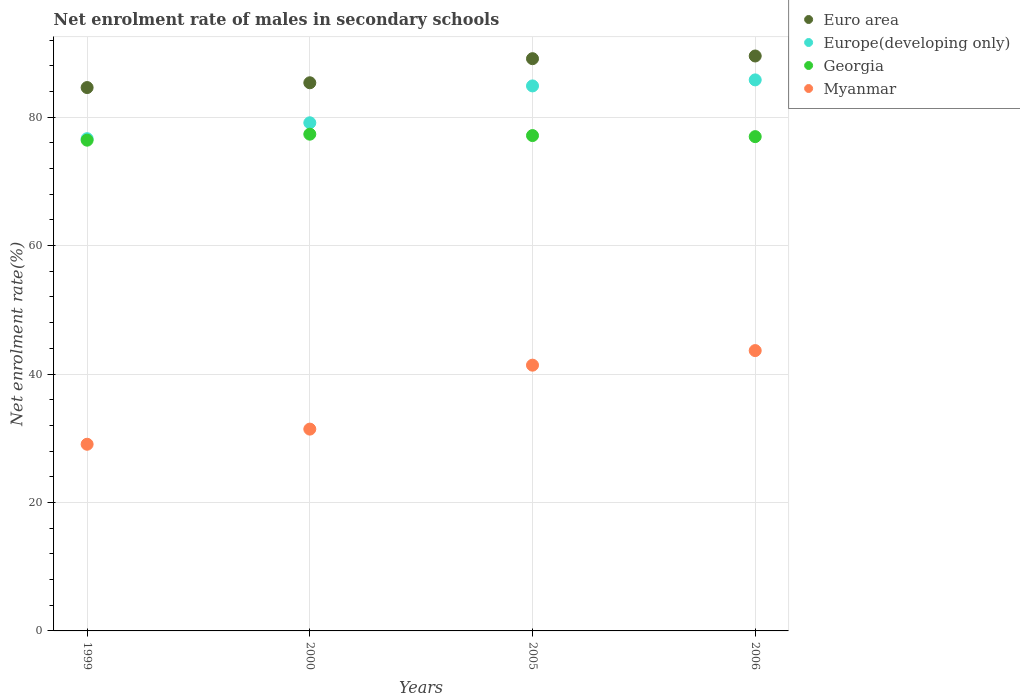What is the net enrolment rate of males in secondary schools in Europe(developing only) in 2000?
Give a very brief answer. 79.12. Across all years, what is the maximum net enrolment rate of males in secondary schools in Euro area?
Your response must be concise. 89.52. Across all years, what is the minimum net enrolment rate of males in secondary schools in Myanmar?
Offer a terse response. 29.06. In which year was the net enrolment rate of males in secondary schools in Myanmar maximum?
Your answer should be very brief. 2006. What is the total net enrolment rate of males in secondary schools in Euro area in the graph?
Your response must be concise. 348.56. What is the difference between the net enrolment rate of males in secondary schools in Euro area in 1999 and that in 2005?
Provide a succinct answer. -4.49. What is the difference between the net enrolment rate of males in secondary schools in Euro area in 2006 and the net enrolment rate of males in secondary schools in Myanmar in 2005?
Keep it short and to the point. 48.14. What is the average net enrolment rate of males in secondary schools in Georgia per year?
Give a very brief answer. 76.96. In the year 1999, what is the difference between the net enrolment rate of males in secondary schools in Georgia and net enrolment rate of males in secondary schools in Myanmar?
Make the answer very short. 47.35. What is the ratio of the net enrolment rate of males in secondary schools in Myanmar in 2000 to that in 2005?
Give a very brief answer. 0.76. Is the difference between the net enrolment rate of males in secondary schools in Georgia in 1999 and 2005 greater than the difference between the net enrolment rate of males in secondary schools in Myanmar in 1999 and 2005?
Offer a terse response. Yes. What is the difference between the highest and the second highest net enrolment rate of males in secondary schools in Georgia?
Ensure brevity in your answer.  0.22. What is the difference between the highest and the lowest net enrolment rate of males in secondary schools in Myanmar?
Your answer should be compact. 14.58. In how many years, is the net enrolment rate of males in secondary schools in Euro area greater than the average net enrolment rate of males in secondary schools in Euro area taken over all years?
Your answer should be very brief. 2. Does the net enrolment rate of males in secondary schools in Georgia monotonically increase over the years?
Provide a short and direct response. No. Is the net enrolment rate of males in secondary schools in Euro area strictly greater than the net enrolment rate of males in secondary schools in Europe(developing only) over the years?
Offer a very short reply. Yes. How many dotlines are there?
Offer a terse response. 4. Are the values on the major ticks of Y-axis written in scientific E-notation?
Make the answer very short. No. How many legend labels are there?
Provide a succinct answer. 4. What is the title of the graph?
Ensure brevity in your answer.  Net enrolment rate of males in secondary schools. What is the label or title of the X-axis?
Your answer should be compact. Years. What is the label or title of the Y-axis?
Offer a terse response. Net enrolment rate(%). What is the Net enrolment rate(%) in Euro area in 1999?
Provide a short and direct response. 84.6. What is the Net enrolment rate(%) in Europe(developing only) in 1999?
Offer a very short reply. 76.64. What is the Net enrolment rate(%) in Georgia in 1999?
Provide a succinct answer. 76.41. What is the Net enrolment rate(%) of Myanmar in 1999?
Your answer should be compact. 29.06. What is the Net enrolment rate(%) of Euro area in 2000?
Keep it short and to the point. 85.35. What is the Net enrolment rate(%) in Europe(developing only) in 2000?
Provide a succinct answer. 79.12. What is the Net enrolment rate(%) of Georgia in 2000?
Give a very brief answer. 77.34. What is the Net enrolment rate(%) in Myanmar in 2000?
Offer a very short reply. 31.42. What is the Net enrolment rate(%) of Euro area in 2005?
Offer a very short reply. 89.1. What is the Net enrolment rate(%) of Europe(developing only) in 2005?
Ensure brevity in your answer.  84.86. What is the Net enrolment rate(%) of Georgia in 2005?
Your answer should be compact. 77.13. What is the Net enrolment rate(%) of Myanmar in 2005?
Your response must be concise. 41.38. What is the Net enrolment rate(%) of Euro area in 2006?
Provide a succinct answer. 89.52. What is the Net enrolment rate(%) of Europe(developing only) in 2006?
Your answer should be very brief. 85.79. What is the Net enrolment rate(%) in Georgia in 2006?
Provide a short and direct response. 76.96. What is the Net enrolment rate(%) of Myanmar in 2006?
Your response must be concise. 43.65. Across all years, what is the maximum Net enrolment rate(%) in Euro area?
Provide a succinct answer. 89.52. Across all years, what is the maximum Net enrolment rate(%) of Europe(developing only)?
Offer a terse response. 85.79. Across all years, what is the maximum Net enrolment rate(%) of Georgia?
Provide a short and direct response. 77.34. Across all years, what is the maximum Net enrolment rate(%) of Myanmar?
Provide a succinct answer. 43.65. Across all years, what is the minimum Net enrolment rate(%) of Euro area?
Offer a terse response. 84.6. Across all years, what is the minimum Net enrolment rate(%) in Europe(developing only)?
Give a very brief answer. 76.64. Across all years, what is the minimum Net enrolment rate(%) in Georgia?
Offer a very short reply. 76.41. Across all years, what is the minimum Net enrolment rate(%) in Myanmar?
Your answer should be compact. 29.06. What is the total Net enrolment rate(%) of Euro area in the graph?
Provide a succinct answer. 348.56. What is the total Net enrolment rate(%) of Europe(developing only) in the graph?
Give a very brief answer. 326.41. What is the total Net enrolment rate(%) of Georgia in the graph?
Offer a terse response. 307.84. What is the total Net enrolment rate(%) of Myanmar in the graph?
Your answer should be very brief. 145.51. What is the difference between the Net enrolment rate(%) of Euro area in 1999 and that in 2000?
Ensure brevity in your answer.  -0.74. What is the difference between the Net enrolment rate(%) in Europe(developing only) in 1999 and that in 2000?
Provide a short and direct response. -2.48. What is the difference between the Net enrolment rate(%) in Georgia in 1999 and that in 2000?
Provide a short and direct response. -0.93. What is the difference between the Net enrolment rate(%) in Myanmar in 1999 and that in 2000?
Offer a very short reply. -2.36. What is the difference between the Net enrolment rate(%) of Euro area in 1999 and that in 2005?
Give a very brief answer. -4.49. What is the difference between the Net enrolment rate(%) in Europe(developing only) in 1999 and that in 2005?
Provide a short and direct response. -8.22. What is the difference between the Net enrolment rate(%) of Georgia in 1999 and that in 2005?
Your answer should be compact. -0.72. What is the difference between the Net enrolment rate(%) of Myanmar in 1999 and that in 2005?
Keep it short and to the point. -12.31. What is the difference between the Net enrolment rate(%) in Euro area in 1999 and that in 2006?
Offer a very short reply. -4.91. What is the difference between the Net enrolment rate(%) in Europe(developing only) in 1999 and that in 2006?
Ensure brevity in your answer.  -9.16. What is the difference between the Net enrolment rate(%) in Georgia in 1999 and that in 2006?
Provide a succinct answer. -0.55. What is the difference between the Net enrolment rate(%) in Myanmar in 1999 and that in 2006?
Offer a terse response. -14.58. What is the difference between the Net enrolment rate(%) of Euro area in 2000 and that in 2005?
Ensure brevity in your answer.  -3.75. What is the difference between the Net enrolment rate(%) of Europe(developing only) in 2000 and that in 2005?
Give a very brief answer. -5.74. What is the difference between the Net enrolment rate(%) in Georgia in 2000 and that in 2005?
Your answer should be compact. 0.22. What is the difference between the Net enrolment rate(%) in Myanmar in 2000 and that in 2005?
Ensure brevity in your answer.  -9.96. What is the difference between the Net enrolment rate(%) of Euro area in 2000 and that in 2006?
Keep it short and to the point. -4.17. What is the difference between the Net enrolment rate(%) in Europe(developing only) in 2000 and that in 2006?
Your answer should be compact. -6.68. What is the difference between the Net enrolment rate(%) in Georgia in 2000 and that in 2006?
Offer a terse response. 0.38. What is the difference between the Net enrolment rate(%) of Myanmar in 2000 and that in 2006?
Make the answer very short. -12.23. What is the difference between the Net enrolment rate(%) in Euro area in 2005 and that in 2006?
Give a very brief answer. -0.42. What is the difference between the Net enrolment rate(%) in Europe(developing only) in 2005 and that in 2006?
Give a very brief answer. -0.94. What is the difference between the Net enrolment rate(%) of Georgia in 2005 and that in 2006?
Make the answer very short. 0.17. What is the difference between the Net enrolment rate(%) in Myanmar in 2005 and that in 2006?
Your response must be concise. -2.27. What is the difference between the Net enrolment rate(%) of Euro area in 1999 and the Net enrolment rate(%) of Europe(developing only) in 2000?
Offer a very short reply. 5.49. What is the difference between the Net enrolment rate(%) of Euro area in 1999 and the Net enrolment rate(%) of Georgia in 2000?
Offer a terse response. 7.26. What is the difference between the Net enrolment rate(%) in Euro area in 1999 and the Net enrolment rate(%) in Myanmar in 2000?
Make the answer very short. 53.18. What is the difference between the Net enrolment rate(%) of Europe(developing only) in 1999 and the Net enrolment rate(%) of Georgia in 2000?
Your answer should be compact. -0.7. What is the difference between the Net enrolment rate(%) in Europe(developing only) in 1999 and the Net enrolment rate(%) in Myanmar in 2000?
Offer a very short reply. 45.22. What is the difference between the Net enrolment rate(%) of Georgia in 1999 and the Net enrolment rate(%) of Myanmar in 2000?
Ensure brevity in your answer.  44.99. What is the difference between the Net enrolment rate(%) in Euro area in 1999 and the Net enrolment rate(%) in Europe(developing only) in 2005?
Your answer should be very brief. -0.25. What is the difference between the Net enrolment rate(%) in Euro area in 1999 and the Net enrolment rate(%) in Georgia in 2005?
Make the answer very short. 7.48. What is the difference between the Net enrolment rate(%) in Euro area in 1999 and the Net enrolment rate(%) in Myanmar in 2005?
Ensure brevity in your answer.  43.22. What is the difference between the Net enrolment rate(%) in Europe(developing only) in 1999 and the Net enrolment rate(%) in Georgia in 2005?
Offer a very short reply. -0.49. What is the difference between the Net enrolment rate(%) in Europe(developing only) in 1999 and the Net enrolment rate(%) in Myanmar in 2005?
Your response must be concise. 35.26. What is the difference between the Net enrolment rate(%) of Georgia in 1999 and the Net enrolment rate(%) of Myanmar in 2005?
Offer a terse response. 35.03. What is the difference between the Net enrolment rate(%) in Euro area in 1999 and the Net enrolment rate(%) in Europe(developing only) in 2006?
Your answer should be compact. -1.19. What is the difference between the Net enrolment rate(%) in Euro area in 1999 and the Net enrolment rate(%) in Georgia in 2006?
Give a very brief answer. 7.64. What is the difference between the Net enrolment rate(%) in Euro area in 1999 and the Net enrolment rate(%) in Myanmar in 2006?
Offer a terse response. 40.95. What is the difference between the Net enrolment rate(%) in Europe(developing only) in 1999 and the Net enrolment rate(%) in Georgia in 2006?
Keep it short and to the point. -0.32. What is the difference between the Net enrolment rate(%) in Europe(developing only) in 1999 and the Net enrolment rate(%) in Myanmar in 2006?
Make the answer very short. 32.99. What is the difference between the Net enrolment rate(%) in Georgia in 1999 and the Net enrolment rate(%) in Myanmar in 2006?
Offer a terse response. 32.76. What is the difference between the Net enrolment rate(%) in Euro area in 2000 and the Net enrolment rate(%) in Europe(developing only) in 2005?
Give a very brief answer. 0.49. What is the difference between the Net enrolment rate(%) of Euro area in 2000 and the Net enrolment rate(%) of Georgia in 2005?
Offer a very short reply. 8.22. What is the difference between the Net enrolment rate(%) in Euro area in 2000 and the Net enrolment rate(%) in Myanmar in 2005?
Give a very brief answer. 43.97. What is the difference between the Net enrolment rate(%) in Europe(developing only) in 2000 and the Net enrolment rate(%) in Georgia in 2005?
Give a very brief answer. 1.99. What is the difference between the Net enrolment rate(%) in Europe(developing only) in 2000 and the Net enrolment rate(%) in Myanmar in 2005?
Provide a short and direct response. 37.74. What is the difference between the Net enrolment rate(%) of Georgia in 2000 and the Net enrolment rate(%) of Myanmar in 2005?
Make the answer very short. 35.96. What is the difference between the Net enrolment rate(%) in Euro area in 2000 and the Net enrolment rate(%) in Europe(developing only) in 2006?
Provide a short and direct response. -0.45. What is the difference between the Net enrolment rate(%) of Euro area in 2000 and the Net enrolment rate(%) of Georgia in 2006?
Provide a short and direct response. 8.39. What is the difference between the Net enrolment rate(%) in Euro area in 2000 and the Net enrolment rate(%) in Myanmar in 2006?
Provide a short and direct response. 41.7. What is the difference between the Net enrolment rate(%) in Europe(developing only) in 2000 and the Net enrolment rate(%) in Georgia in 2006?
Provide a succinct answer. 2.16. What is the difference between the Net enrolment rate(%) in Europe(developing only) in 2000 and the Net enrolment rate(%) in Myanmar in 2006?
Make the answer very short. 35.47. What is the difference between the Net enrolment rate(%) in Georgia in 2000 and the Net enrolment rate(%) in Myanmar in 2006?
Keep it short and to the point. 33.69. What is the difference between the Net enrolment rate(%) of Euro area in 2005 and the Net enrolment rate(%) of Europe(developing only) in 2006?
Your answer should be very brief. 3.3. What is the difference between the Net enrolment rate(%) in Euro area in 2005 and the Net enrolment rate(%) in Georgia in 2006?
Offer a terse response. 12.14. What is the difference between the Net enrolment rate(%) of Euro area in 2005 and the Net enrolment rate(%) of Myanmar in 2006?
Give a very brief answer. 45.45. What is the difference between the Net enrolment rate(%) of Europe(developing only) in 2005 and the Net enrolment rate(%) of Georgia in 2006?
Keep it short and to the point. 7.9. What is the difference between the Net enrolment rate(%) in Europe(developing only) in 2005 and the Net enrolment rate(%) in Myanmar in 2006?
Offer a terse response. 41.21. What is the difference between the Net enrolment rate(%) in Georgia in 2005 and the Net enrolment rate(%) in Myanmar in 2006?
Ensure brevity in your answer.  33.48. What is the average Net enrolment rate(%) of Euro area per year?
Keep it short and to the point. 87.14. What is the average Net enrolment rate(%) of Europe(developing only) per year?
Keep it short and to the point. 81.6. What is the average Net enrolment rate(%) of Georgia per year?
Provide a succinct answer. 76.96. What is the average Net enrolment rate(%) of Myanmar per year?
Provide a succinct answer. 36.38. In the year 1999, what is the difference between the Net enrolment rate(%) in Euro area and Net enrolment rate(%) in Europe(developing only)?
Your answer should be very brief. 7.96. In the year 1999, what is the difference between the Net enrolment rate(%) in Euro area and Net enrolment rate(%) in Georgia?
Give a very brief answer. 8.19. In the year 1999, what is the difference between the Net enrolment rate(%) in Euro area and Net enrolment rate(%) in Myanmar?
Your response must be concise. 55.54. In the year 1999, what is the difference between the Net enrolment rate(%) in Europe(developing only) and Net enrolment rate(%) in Georgia?
Make the answer very short. 0.23. In the year 1999, what is the difference between the Net enrolment rate(%) in Europe(developing only) and Net enrolment rate(%) in Myanmar?
Offer a terse response. 47.57. In the year 1999, what is the difference between the Net enrolment rate(%) in Georgia and Net enrolment rate(%) in Myanmar?
Your response must be concise. 47.35. In the year 2000, what is the difference between the Net enrolment rate(%) of Euro area and Net enrolment rate(%) of Europe(developing only)?
Ensure brevity in your answer.  6.23. In the year 2000, what is the difference between the Net enrolment rate(%) in Euro area and Net enrolment rate(%) in Georgia?
Ensure brevity in your answer.  8. In the year 2000, what is the difference between the Net enrolment rate(%) in Euro area and Net enrolment rate(%) in Myanmar?
Provide a short and direct response. 53.92. In the year 2000, what is the difference between the Net enrolment rate(%) in Europe(developing only) and Net enrolment rate(%) in Georgia?
Your answer should be very brief. 1.78. In the year 2000, what is the difference between the Net enrolment rate(%) in Europe(developing only) and Net enrolment rate(%) in Myanmar?
Your answer should be compact. 47.7. In the year 2000, what is the difference between the Net enrolment rate(%) in Georgia and Net enrolment rate(%) in Myanmar?
Your answer should be very brief. 45.92. In the year 2005, what is the difference between the Net enrolment rate(%) of Euro area and Net enrolment rate(%) of Europe(developing only)?
Make the answer very short. 4.24. In the year 2005, what is the difference between the Net enrolment rate(%) of Euro area and Net enrolment rate(%) of Georgia?
Offer a terse response. 11.97. In the year 2005, what is the difference between the Net enrolment rate(%) of Euro area and Net enrolment rate(%) of Myanmar?
Keep it short and to the point. 47.72. In the year 2005, what is the difference between the Net enrolment rate(%) in Europe(developing only) and Net enrolment rate(%) in Georgia?
Your answer should be compact. 7.73. In the year 2005, what is the difference between the Net enrolment rate(%) in Europe(developing only) and Net enrolment rate(%) in Myanmar?
Provide a succinct answer. 43.48. In the year 2005, what is the difference between the Net enrolment rate(%) of Georgia and Net enrolment rate(%) of Myanmar?
Provide a short and direct response. 35.75. In the year 2006, what is the difference between the Net enrolment rate(%) in Euro area and Net enrolment rate(%) in Europe(developing only)?
Provide a short and direct response. 3.72. In the year 2006, what is the difference between the Net enrolment rate(%) of Euro area and Net enrolment rate(%) of Georgia?
Give a very brief answer. 12.56. In the year 2006, what is the difference between the Net enrolment rate(%) in Euro area and Net enrolment rate(%) in Myanmar?
Keep it short and to the point. 45.87. In the year 2006, what is the difference between the Net enrolment rate(%) of Europe(developing only) and Net enrolment rate(%) of Georgia?
Your answer should be very brief. 8.84. In the year 2006, what is the difference between the Net enrolment rate(%) of Europe(developing only) and Net enrolment rate(%) of Myanmar?
Offer a very short reply. 42.15. In the year 2006, what is the difference between the Net enrolment rate(%) of Georgia and Net enrolment rate(%) of Myanmar?
Offer a terse response. 33.31. What is the ratio of the Net enrolment rate(%) in Europe(developing only) in 1999 to that in 2000?
Offer a very short reply. 0.97. What is the ratio of the Net enrolment rate(%) in Myanmar in 1999 to that in 2000?
Provide a short and direct response. 0.93. What is the ratio of the Net enrolment rate(%) of Euro area in 1999 to that in 2005?
Make the answer very short. 0.95. What is the ratio of the Net enrolment rate(%) in Europe(developing only) in 1999 to that in 2005?
Ensure brevity in your answer.  0.9. What is the ratio of the Net enrolment rate(%) in Myanmar in 1999 to that in 2005?
Your response must be concise. 0.7. What is the ratio of the Net enrolment rate(%) in Euro area in 1999 to that in 2006?
Provide a succinct answer. 0.95. What is the ratio of the Net enrolment rate(%) of Europe(developing only) in 1999 to that in 2006?
Keep it short and to the point. 0.89. What is the ratio of the Net enrolment rate(%) in Myanmar in 1999 to that in 2006?
Provide a short and direct response. 0.67. What is the ratio of the Net enrolment rate(%) of Euro area in 2000 to that in 2005?
Offer a terse response. 0.96. What is the ratio of the Net enrolment rate(%) in Europe(developing only) in 2000 to that in 2005?
Your response must be concise. 0.93. What is the ratio of the Net enrolment rate(%) of Georgia in 2000 to that in 2005?
Keep it short and to the point. 1. What is the ratio of the Net enrolment rate(%) in Myanmar in 2000 to that in 2005?
Make the answer very short. 0.76. What is the ratio of the Net enrolment rate(%) in Euro area in 2000 to that in 2006?
Your answer should be compact. 0.95. What is the ratio of the Net enrolment rate(%) in Europe(developing only) in 2000 to that in 2006?
Your answer should be compact. 0.92. What is the ratio of the Net enrolment rate(%) of Georgia in 2000 to that in 2006?
Offer a very short reply. 1. What is the ratio of the Net enrolment rate(%) of Myanmar in 2000 to that in 2006?
Offer a terse response. 0.72. What is the ratio of the Net enrolment rate(%) in Georgia in 2005 to that in 2006?
Give a very brief answer. 1. What is the ratio of the Net enrolment rate(%) in Myanmar in 2005 to that in 2006?
Offer a terse response. 0.95. What is the difference between the highest and the second highest Net enrolment rate(%) in Euro area?
Offer a terse response. 0.42. What is the difference between the highest and the second highest Net enrolment rate(%) in Europe(developing only)?
Your answer should be very brief. 0.94. What is the difference between the highest and the second highest Net enrolment rate(%) in Georgia?
Make the answer very short. 0.22. What is the difference between the highest and the second highest Net enrolment rate(%) in Myanmar?
Ensure brevity in your answer.  2.27. What is the difference between the highest and the lowest Net enrolment rate(%) of Euro area?
Give a very brief answer. 4.91. What is the difference between the highest and the lowest Net enrolment rate(%) in Europe(developing only)?
Your answer should be very brief. 9.16. What is the difference between the highest and the lowest Net enrolment rate(%) of Georgia?
Your answer should be compact. 0.93. What is the difference between the highest and the lowest Net enrolment rate(%) in Myanmar?
Your answer should be very brief. 14.58. 